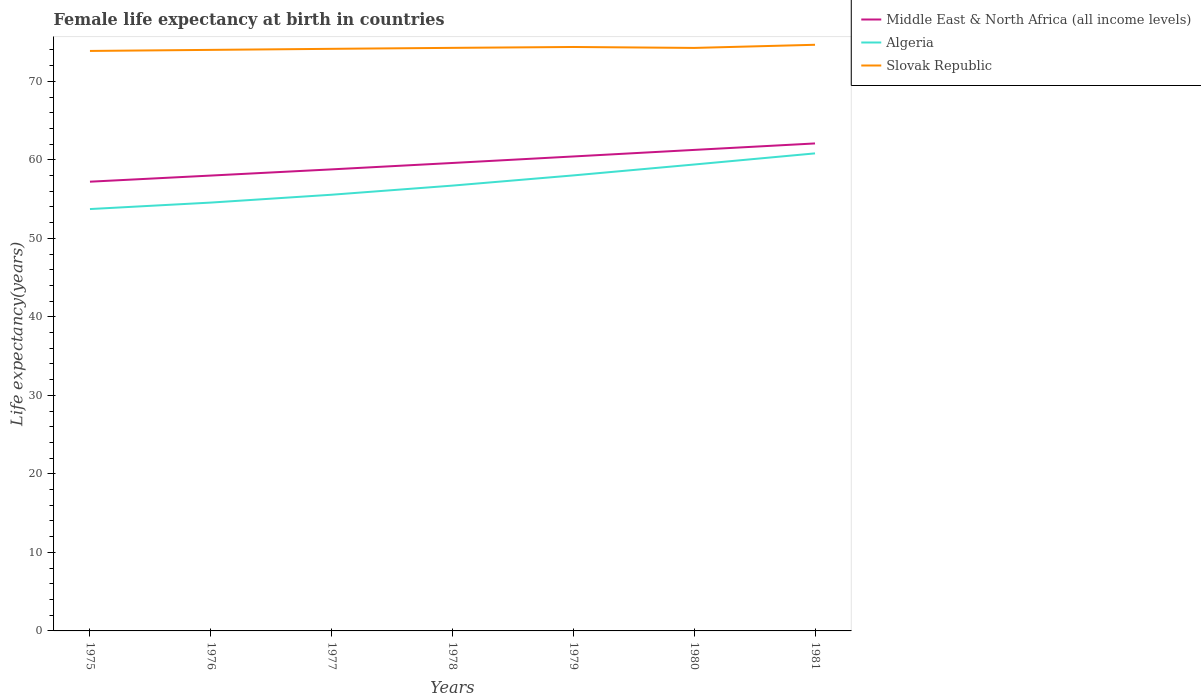Is the number of lines equal to the number of legend labels?
Offer a terse response. Yes. Across all years, what is the maximum female life expectancy at birth in Slovak Republic?
Ensure brevity in your answer.  73.87. In which year was the female life expectancy at birth in Slovak Republic maximum?
Your answer should be compact. 1975. What is the total female life expectancy at birth in Algeria in the graph?
Offer a very short reply. -1.39. What is the difference between the highest and the second highest female life expectancy at birth in Slovak Republic?
Offer a terse response. 0.78. Is the female life expectancy at birth in Slovak Republic strictly greater than the female life expectancy at birth in Middle East & North Africa (all income levels) over the years?
Offer a very short reply. No. What is the difference between two consecutive major ticks on the Y-axis?
Make the answer very short. 10. Are the values on the major ticks of Y-axis written in scientific E-notation?
Give a very brief answer. No. Does the graph contain any zero values?
Offer a very short reply. No. How many legend labels are there?
Make the answer very short. 3. How are the legend labels stacked?
Offer a terse response. Vertical. What is the title of the graph?
Give a very brief answer. Female life expectancy at birth in countries. What is the label or title of the Y-axis?
Offer a very short reply. Life expectancy(years). What is the Life expectancy(years) in Middle East & North Africa (all income levels) in 1975?
Your answer should be very brief. 57.21. What is the Life expectancy(years) in Algeria in 1975?
Offer a terse response. 53.73. What is the Life expectancy(years) in Slovak Republic in 1975?
Your answer should be very brief. 73.87. What is the Life expectancy(years) of Middle East & North Africa (all income levels) in 1976?
Offer a very short reply. 57.99. What is the Life expectancy(years) in Algeria in 1976?
Keep it short and to the point. 54.55. What is the Life expectancy(years) of Slovak Republic in 1976?
Keep it short and to the point. 74. What is the Life expectancy(years) in Middle East & North Africa (all income levels) in 1977?
Keep it short and to the point. 58.78. What is the Life expectancy(years) in Algeria in 1977?
Provide a succinct answer. 55.55. What is the Life expectancy(years) of Slovak Republic in 1977?
Give a very brief answer. 74.14. What is the Life expectancy(years) in Middle East & North Africa (all income levels) in 1978?
Ensure brevity in your answer.  59.6. What is the Life expectancy(years) in Algeria in 1978?
Offer a terse response. 56.72. What is the Life expectancy(years) in Slovak Republic in 1978?
Your answer should be compact. 74.26. What is the Life expectancy(years) of Middle East & North Africa (all income levels) in 1979?
Ensure brevity in your answer.  60.43. What is the Life expectancy(years) in Algeria in 1979?
Offer a terse response. 58.01. What is the Life expectancy(years) of Slovak Republic in 1979?
Ensure brevity in your answer.  74.37. What is the Life expectancy(years) of Middle East & North Africa (all income levels) in 1980?
Keep it short and to the point. 61.26. What is the Life expectancy(years) of Algeria in 1980?
Give a very brief answer. 59.4. What is the Life expectancy(years) in Slovak Republic in 1980?
Your answer should be compact. 74.25. What is the Life expectancy(years) in Middle East & North Africa (all income levels) in 1981?
Make the answer very short. 62.09. What is the Life expectancy(years) of Algeria in 1981?
Your answer should be very brief. 60.82. What is the Life expectancy(years) in Slovak Republic in 1981?
Your answer should be very brief. 74.65. Across all years, what is the maximum Life expectancy(years) in Middle East & North Africa (all income levels)?
Provide a short and direct response. 62.09. Across all years, what is the maximum Life expectancy(years) in Algeria?
Provide a succinct answer. 60.82. Across all years, what is the maximum Life expectancy(years) of Slovak Republic?
Your answer should be very brief. 74.65. Across all years, what is the minimum Life expectancy(years) in Middle East & North Africa (all income levels)?
Make the answer very short. 57.21. Across all years, what is the minimum Life expectancy(years) of Algeria?
Provide a short and direct response. 53.73. Across all years, what is the minimum Life expectancy(years) of Slovak Republic?
Offer a terse response. 73.87. What is the total Life expectancy(years) in Middle East & North Africa (all income levels) in the graph?
Your answer should be very brief. 417.36. What is the total Life expectancy(years) of Algeria in the graph?
Your response must be concise. 398.79. What is the total Life expectancy(years) in Slovak Republic in the graph?
Give a very brief answer. 519.53. What is the difference between the Life expectancy(years) of Middle East & North Africa (all income levels) in 1975 and that in 1976?
Your answer should be very brief. -0.78. What is the difference between the Life expectancy(years) in Algeria in 1975 and that in 1976?
Your answer should be compact. -0.82. What is the difference between the Life expectancy(years) of Slovak Republic in 1975 and that in 1976?
Provide a succinct answer. -0.14. What is the difference between the Life expectancy(years) in Middle East & North Africa (all income levels) in 1975 and that in 1977?
Provide a short and direct response. -1.57. What is the difference between the Life expectancy(years) of Algeria in 1975 and that in 1977?
Give a very brief answer. -1.82. What is the difference between the Life expectancy(years) in Slovak Republic in 1975 and that in 1977?
Give a very brief answer. -0.27. What is the difference between the Life expectancy(years) in Middle East & North Africa (all income levels) in 1975 and that in 1978?
Make the answer very short. -2.38. What is the difference between the Life expectancy(years) in Algeria in 1975 and that in 1978?
Offer a very short reply. -2.99. What is the difference between the Life expectancy(years) in Slovak Republic in 1975 and that in 1978?
Give a very brief answer. -0.39. What is the difference between the Life expectancy(years) in Middle East & North Africa (all income levels) in 1975 and that in 1979?
Provide a short and direct response. -3.21. What is the difference between the Life expectancy(years) of Algeria in 1975 and that in 1979?
Ensure brevity in your answer.  -4.29. What is the difference between the Life expectancy(years) in Slovak Republic in 1975 and that in 1979?
Keep it short and to the point. -0.5. What is the difference between the Life expectancy(years) in Middle East & North Africa (all income levels) in 1975 and that in 1980?
Give a very brief answer. -4.05. What is the difference between the Life expectancy(years) in Algeria in 1975 and that in 1980?
Your answer should be very brief. -5.67. What is the difference between the Life expectancy(years) in Slovak Republic in 1975 and that in 1980?
Provide a short and direct response. -0.38. What is the difference between the Life expectancy(years) of Middle East & North Africa (all income levels) in 1975 and that in 1981?
Offer a very short reply. -4.87. What is the difference between the Life expectancy(years) in Algeria in 1975 and that in 1981?
Ensure brevity in your answer.  -7.09. What is the difference between the Life expectancy(years) of Slovak Republic in 1975 and that in 1981?
Make the answer very short. -0.78. What is the difference between the Life expectancy(years) in Middle East & North Africa (all income levels) in 1976 and that in 1977?
Your answer should be very brief. -0.79. What is the difference between the Life expectancy(years) in Algeria in 1976 and that in 1977?
Keep it short and to the point. -1. What is the difference between the Life expectancy(years) in Slovak Republic in 1976 and that in 1977?
Make the answer very short. -0.13. What is the difference between the Life expectancy(years) of Middle East & North Africa (all income levels) in 1976 and that in 1978?
Ensure brevity in your answer.  -1.6. What is the difference between the Life expectancy(years) of Algeria in 1976 and that in 1978?
Your answer should be compact. -2.16. What is the difference between the Life expectancy(years) in Slovak Republic in 1976 and that in 1978?
Keep it short and to the point. -0.26. What is the difference between the Life expectancy(years) in Middle East & North Africa (all income levels) in 1976 and that in 1979?
Your answer should be compact. -2.43. What is the difference between the Life expectancy(years) of Algeria in 1976 and that in 1979?
Make the answer very short. -3.46. What is the difference between the Life expectancy(years) in Slovak Republic in 1976 and that in 1979?
Offer a very short reply. -0.37. What is the difference between the Life expectancy(years) in Middle East & North Africa (all income levels) in 1976 and that in 1980?
Offer a terse response. -3.27. What is the difference between the Life expectancy(years) in Algeria in 1976 and that in 1980?
Keep it short and to the point. -4.85. What is the difference between the Life expectancy(years) of Slovak Republic in 1976 and that in 1980?
Offer a terse response. -0.25. What is the difference between the Life expectancy(years) of Middle East & North Africa (all income levels) in 1976 and that in 1981?
Offer a very short reply. -4.09. What is the difference between the Life expectancy(years) of Algeria in 1976 and that in 1981?
Your answer should be very brief. -6.27. What is the difference between the Life expectancy(years) of Slovak Republic in 1976 and that in 1981?
Keep it short and to the point. -0.65. What is the difference between the Life expectancy(years) of Middle East & North Africa (all income levels) in 1977 and that in 1978?
Ensure brevity in your answer.  -0.82. What is the difference between the Life expectancy(years) in Algeria in 1977 and that in 1978?
Provide a succinct answer. -1.16. What is the difference between the Life expectancy(years) of Slovak Republic in 1977 and that in 1978?
Provide a succinct answer. -0.12. What is the difference between the Life expectancy(years) in Middle East & North Africa (all income levels) in 1977 and that in 1979?
Offer a terse response. -1.65. What is the difference between the Life expectancy(years) of Algeria in 1977 and that in 1979?
Provide a succinct answer. -2.46. What is the difference between the Life expectancy(years) in Slovak Republic in 1977 and that in 1979?
Give a very brief answer. -0.23. What is the difference between the Life expectancy(years) of Middle East & North Africa (all income levels) in 1977 and that in 1980?
Make the answer very short. -2.48. What is the difference between the Life expectancy(years) of Algeria in 1977 and that in 1980?
Your answer should be compact. -3.85. What is the difference between the Life expectancy(years) in Slovak Republic in 1977 and that in 1980?
Your answer should be very brief. -0.12. What is the difference between the Life expectancy(years) in Middle East & North Africa (all income levels) in 1977 and that in 1981?
Make the answer very short. -3.3. What is the difference between the Life expectancy(years) of Algeria in 1977 and that in 1981?
Ensure brevity in your answer.  -5.27. What is the difference between the Life expectancy(years) of Slovak Republic in 1977 and that in 1981?
Provide a short and direct response. -0.52. What is the difference between the Life expectancy(years) of Middle East & North Africa (all income levels) in 1978 and that in 1979?
Your response must be concise. -0.83. What is the difference between the Life expectancy(years) of Algeria in 1978 and that in 1979?
Provide a succinct answer. -1.3. What is the difference between the Life expectancy(years) of Slovak Republic in 1978 and that in 1979?
Give a very brief answer. -0.11. What is the difference between the Life expectancy(years) in Middle East & North Africa (all income levels) in 1978 and that in 1980?
Your answer should be very brief. -1.66. What is the difference between the Life expectancy(years) of Algeria in 1978 and that in 1980?
Your answer should be compact. -2.69. What is the difference between the Life expectancy(years) in Slovak Republic in 1978 and that in 1980?
Give a very brief answer. 0.01. What is the difference between the Life expectancy(years) in Middle East & North Africa (all income levels) in 1978 and that in 1981?
Ensure brevity in your answer.  -2.49. What is the difference between the Life expectancy(years) of Algeria in 1978 and that in 1981?
Offer a terse response. -4.1. What is the difference between the Life expectancy(years) of Slovak Republic in 1978 and that in 1981?
Provide a short and direct response. -0.39. What is the difference between the Life expectancy(years) of Middle East & North Africa (all income levels) in 1979 and that in 1980?
Your answer should be very brief. -0.83. What is the difference between the Life expectancy(years) in Algeria in 1979 and that in 1980?
Give a very brief answer. -1.39. What is the difference between the Life expectancy(years) of Slovak Republic in 1979 and that in 1980?
Keep it short and to the point. 0.12. What is the difference between the Life expectancy(years) of Middle East & North Africa (all income levels) in 1979 and that in 1981?
Your answer should be compact. -1.66. What is the difference between the Life expectancy(years) of Algeria in 1979 and that in 1981?
Your answer should be compact. -2.81. What is the difference between the Life expectancy(years) of Slovak Republic in 1979 and that in 1981?
Make the answer very short. -0.28. What is the difference between the Life expectancy(years) in Middle East & North Africa (all income levels) in 1980 and that in 1981?
Provide a short and direct response. -0.82. What is the difference between the Life expectancy(years) of Algeria in 1980 and that in 1981?
Make the answer very short. -1.42. What is the difference between the Life expectancy(years) in Slovak Republic in 1980 and that in 1981?
Offer a terse response. -0.4. What is the difference between the Life expectancy(years) of Middle East & North Africa (all income levels) in 1975 and the Life expectancy(years) of Algeria in 1976?
Keep it short and to the point. 2.66. What is the difference between the Life expectancy(years) in Middle East & North Africa (all income levels) in 1975 and the Life expectancy(years) in Slovak Republic in 1976?
Ensure brevity in your answer.  -16.79. What is the difference between the Life expectancy(years) of Algeria in 1975 and the Life expectancy(years) of Slovak Republic in 1976?
Your answer should be very brief. -20.27. What is the difference between the Life expectancy(years) of Middle East & North Africa (all income levels) in 1975 and the Life expectancy(years) of Algeria in 1977?
Ensure brevity in your answer.  1.66. What is the difference between the Life expectancy(years) of Middle East & North Africa (all income levels) in 1975 and the Life expectancy(years) of Slovak Republic in 1977?
Provide a short and direct response. -16.92. What is the difference between the Life expectancy(years) in Algeria in 1975 and the Life expectancy(years) in Slovak Republic in 1977?
Provide a succinct answer. -20.41. What is the difference between the Life expectancy(years) of Middle East & North Africa (all income levels) in 1975 and the Life expectancy(years) of Algeria in 1978?
Make the answer very short. 0.5. What is the difference between the Life expectancy(years) in Middle East & North Africa (all income levels) in 1975 and the Life expectancy(years) in Slovak Republic in 1978?
Offer a very short reply. -17.04. What is the difference between the Life expectancy(years) of Algeria in 1975 and the Life expectancy(years) of Slovak Republic in 1978?
Offer a terse response. -20.53. What is the difference between the Life expectancy(years) of Middle East & North Africa (all income levels) in 1975 and the Life expectancy(years) of Algeria in 1979?
Your answer should be very brief. -0.8. What is the difference between the Life expectancy(years) in Middle East & North Africa (all income levels) in 1975 and the Life expectancy(years) in Slovak Republic in 1979?
Provide a succinct answer. -17.16. What is the difference between the Life expectancy(years) of Algeria in 1975 and the Life expectancy(years) of Slovak Republic in 1979?
Make the answer very short. -20.64. What is the difference between the Life expectancy(years) of Middle East & North Africa (all income levels) in 1975 and the Life expectancy(years) of Algeria in 1980?
Offer a terse response. -2.19. What is the difference between the Life expectancy(years) of Middle East & North Africa (all income levels) in 1975 and the Life expectancy(years) of Slovak Republic in 1980?
Make the answer very short. -17.04. What is the difference between the Life expectancy(years) in Algeria in 1975 and the Life expectancy(years) in Slovak Republic in 1980?
Offer a very short reply. -20.52. What is the difference between the Life expectancy(years) in Middle East & North Africa (all income levels) in 1975 and the Life expectancy(years) in Algeria in 1981?
Offer a terse response. -3.61. What is the difference between the Life expectancy(years) in Middle East & North Africa (all income levels) in 1975 and the Life expectancy(years) in Slovak Republic in 1981?
Offer a very short reply. -17.44. What is the difference between the Life expectancy(years) of Algeria in 1975 and the Life expectancy(years) of Slovak Republic in 1981?
Your answer should be very brief. -20.92. What is the difference between the Life expectancy(years) of Middle East & North Africa (all income levels) in 1976 and the Life expectancy(years) of Algeria in 1977?
Your answer should be very brief. 2.44. What is the difference between the Life expectancy(years) in Middle East & North Africa (all income levels) in 1976 and the Life expectancy(years) in Slovak Republic in 1977?
Give a very brief answer. -16.14. What is the difference between the Life expectancy(years) of Algeria in 1976 and the Life expectancy(years) of Slovak Republic in 1977?
Give a very brief answer. -19.58. What is the difference between the Life expectancy(years) of Middle East & North Africa (all income levels) in 1976 and the Life expectancy(years) of Algeria in 1978?
Offer a very short reply. 1.28. What is the difference between the Life expectancy(years) of Middle East & North Africa (all income levels) in 1976 and the Life expectancy(years) of Slovak Republic in 1978?
Your response must be concise. -16.27. What is the difference between the Life expectancy(years) of Algeria in 1976 and the Life expectancy(years) of Slovak Republic in 1978?
Offer a very short reply. -19.7. What is the difference between the Life expectancy(years) in Middle East & North Africa (all income levels) in 1976 and the Life expectancy(years) in Algeria in 1979?
Provide a short and direct response. -0.02. What is the difference between the Life expectancy(years) in Middle East & North Africa (all income levels) in 1976 and the Life expectancy(years) in Slovak Republic in 1979?
Make the answer very short. -16.38. What is the difference between the Life expectancy(years) in Algeria in 1976 and the Life expectancy(years) in Slovak Republic in 1979?
Give a very brief answer. -19.82. What is the difference between the Life expectancy(years) in Middle East & North Africa (all income levels) in 1976 and the Life expectancy(years) in Algeria in 1980?
Offer a terse response. -1.41. What is the difference between the Life expectancy(years) in Middle East & North Africa (all income levels) in 1976 and the Life expectancy(years) in Slovak Republic in 1980?
Offer a very short reply. -16.26. What is the difference between the Life expectancy(years) of Algeria in 1976 and the Life expectancy(years) of Slovak Republic in 1980?
Provide a short and direct response. -19.7. What is the difference between the Life expectancy(years) in Middle East & North Africa (all income levels) in 1976 and the Life expectancy(years) in Algeria in 1981?
Provide a short and direct response. -2.83. What is the difference between the Life expectancy(years) of Middle East & North Africa (all income levels) in 1976 and the Life expectancy(years) of Slovak Republic in 1981?
Provide a short and direct response. -16.66. What is the difference between the Life expectancy(years) of Algeria in 1976 and the Life expectancy(years) of Slovak Republic in 1981?
Provide a short and direct response. -20.1. What is the difference between the Life expectancy(years) of Middle East & North Africa (all income levels) in 1977 and the Life expectancy(years) of Algeria in 1978?
Offer a terse response. 2.07. What is the difference between the Life expectancy(years) of Middle East & North Africa (all income levels) in 1977 and the Life expectancy(years) of Slovak Republic in 1978?
Your answer should be compact. -15.48. What is the difference between the Life expectancy(years) of Algeria in 1977 and the Life expectancy(years) of Slovak Republic in 1978?
Offer a terse response. -18.7. What is the difference between the Life expectancy(years) of Middle East & North Africa (all income levels) in 1977 and the Life expectancy(years) of Algeria in 1979?
Give a very brief answer. 0.77. What is the difference between the Life expectancy(years) in Middle East & North Africa (all income levels) in 1977 and the Life expectancy(years) in Slovak Republic in 1979?
Provide a short and direct response. -15.59. What is the difference between the Life expectancy(years) of Algeria in 1977 and the Life expectancy(years) of Slovak Republic in 1979?
Your answer should be compact. -18.82. What is the difference between the Life expectancy(years) in Middle East & North Africa (all income levels) in 1977 and the Life expectancy(years) in Algeria in 1980?
Give a very brief answer. -0.62. What is the difference between the Life expectancy(years) in Middle East & North Africa (all income levels) in 1977 and the Life expectancy(years) in Slovak Republic in 1980?
Your response must be concise. -15.47. What is the difference between the Life expectancy(years) in Algeria in 1977 and the Life expectancy(years) in Slovak Republic in 1980?
Provide a short and direct response. -18.7. What is the difference between the Life expectancy(years) of Middle East & North Africa (all income levels) in 1977 and the Life expectancy(years) of Algeria in 1981?
Provide a short and direct response. -2.04. What is the difference between the Life expectancy(years) of Middle East & North Africa (all income levels) in 1977 and the Life expectancy(years) of Slovak Republic in 1981?
Your response must be concise. -15.87. What is the difference between the Life expectancy(years) of Algeria in 1977 and the Life expectancy(years) of Slovak Republic in 1981?
Offer a very short reply. -19.1. What is the difference between the Life expectancy(years) in Middle East & North Africa (all income levels) in 1978 and the Life expectancy(years) in Algeria in 1979?
Keep it short and to the point. 1.58. What is the difference between the Life expectancy(years) in Middle East & North Africa (all income levels) in 1978 and the Life expectancy(years) in Slovak Republic in 1979?
Keep it short and to the point. -14.77. What is the difference between the Life expectancy(years) of Algeria in 1978 and the Life expectancy(years) of Slovak Republic in 1979?
Offer a terse response. -17.65. What is the difference between the Life expectancy(years) of Middle East & North Africa (all income levels) in 1978 and the Life expectancy(years) of Algeria in 1980?
Your answer should be very brief. 0.2. What is the difference between the Life expectancy(years) of Middle East & North Africa (all income levels) in 1978 and the Life expectancy(years) of Slovak Republic in 1980?
Provide a succinct answer. -14.65. What is the difference between the Life expectancy(years) of Algeria in 1978 and the Life expectancy(years) of Slovak Republic in 1980?
Provide a short and direct response. -17.53. What is the difference between the Life expectancy(years) in Middle East & North Africa (all income levels) in 1978 and the Life expectancy(years) in Algeria in 1981?
Offer a terse response. -1.22. What is the difference between the Life expectancy(years) in Middle East & North Africa (all income levels) in 1978 and the Life expectancy(years) in Slovak Republic in 1981?
Give a very brief answer. -15.05. What is the difference between the Life expectancy(years) of Algeria in 1978 and the Life expectancy(years) of Slovak Republic in 1981?
Ensure brevity in your answer.  -17.93. What is the difference between the Life expectancy(years) in Middle East & North Africa (all income levels) in 1979 and the Life expectancy(years) in Algeria in 1980?
Your answer should be very brief. 1.03. What is the difference between the Life expectancy(years) of Middle East & North Africa (all income levels) in 1979 and the Life expectancy(years) of Slovak Republic in 1980?
Your response must be concise. -13.82. What is the difference between the Life expectancy(years) in Algeria in 1979 and the Life expectancy(years) in Slovak Republic in 1980?
Keep it short and to the point. -16.24. What is the difference between the Life expectancy(years) of Middle East & North Africa (all income levels) in 1979 and the Life expectancy(years) of Algeria in 1981?
Provide a short and direct response. -0.39. What is the difference between the Life expectancy(years) of Middle East & North Africa (all income levels) in 1979 and the Life expectancy(years) of Slovak Republic in 1981?
Your answer should be compact. -14.22. What is the difference between the Life expectancy(years) in Algeria in 1979 and the Life expectancy(years) in Slovak Republic in 1981?
Keep it short and to the point. -16.64. What is the difference between the Life expectancy(years) of Middle East & North Africa (all income levels) in 1980 and the Life expectancy(years) of Algeria in 1981?
Ensure brevity in your answer.  0.44. What is the difference between the Life expectancy(years) of Middle East & North Africa (all income levels) in 1980 and the Life expectancy(years) of Slovak Republic in 1981?
Provide a short and direct response. -13.39. What is the difference between the Life expectancy(years) of Algeria in 1980 and the Life expectancy(years) of Slovak Republic in 1981?
Your answer should be compact. -15.25. What is the average Life expectancy(years) of Middle East & North Africa (all income levels) per year?
Your answer should be compact. 59.62. What is the average Life expectancy(years) in Algeria per year?
Provide a succinct answer. 56.97. What is the average Life expectancy(years) of Slovak Republic per year?
Give a very brief answer. 74.22. In the year 1975, what is the difference between the Life expectancy(years) in Middle East & North Africa (all income levels) and Life expectancy(years) in Algeria?
Your answer should be compact. 3.49. In the year 1975, what is the difference between the Life expectancy(years) of Middle East & North Africa (all income levels) and Life expectancy(years) of Slovak Republic?
Give a very brief answer. -16.65. In the year 1975, what is the difference between the Life expectancy(years) of Algeria and Life expectancy(years) of Slovak Republic?
Ensure brevity in your answer.  -20.14. In the year 1976, what is the difference between the Life expectancy(years) of Middle East & North Africa (all income levels) and Life expectancy(years) of Algeria?
Provide a short and direct response. 3.44. In the year 1976, what is the difference between the Life expectancy(years) of Middle East & North Africa (all income levels) and Life expectancy(years) of Slovak Republic?
Make the answer very short. -16.01. In the year 1976, what is the difference between the Life expectancy(years) in Algeria and Life expectancy(years) in Slovak Republic?
Your answer should be compact. -19.45. In the year 1977, what is the difference between the Life expectancy(years) in Middle East & North Africa (all income levels) and Life expectancy(years) in Algeria?
Keep it short and to the point. 3.23. In the year 1977, what is the difference between the Life expectancy(years) in Middle East & North Africa (all income levels) and Life expectancy(years) in Slovak Republic?
Your answer should be compact. -15.35. In the year 1977, what is the difference between the Life expectancy(years) in Algeria and Life expectancy(years) in Slovak Republic?
Your answer should be very brief. -18.58. In the year 1978, what is the difference between the Life expectancy(years) of Middle East & North Africa (all income levels) and Life expectancy(years) of Algeria?
Make the answer very short. 2.88. In the year 1978, what is the difference between the Life expectancy(years) in Middle East & North Africa (all income levels) and Life expectancy(years) in Slovak Republic?
Provide a short and direct response. -14.66. In the year 1978, what is the difference between the Life expectancy(years) of Algeria and Life expectancy(years) of Slovak Republic?
Make the answer very short. -17.54. In the year 1979, what is the difference between the Life expectancy(years) of Middle East & North Africa (all income levels) and Life expectancy(years) of Algeria?
Your answer should be compact. 2.41. In the year 1979, what is the difference between the Life expectancy(years) in Middle East & North Africa (all income levels) and Life expectancy(years) in Slovak Republic?
Offer a very short reply. -13.94. In the year 1979, what is the difference between the Life expectancy(years) in Algeria and Life expectancy(years) in Slovak Republic?
Keep it short and to the point. -16.36. In the year 1980, what is the difference between the Life expectancy(years) of Middle East & North Africa (all income levels) and Life expectancy(years) of Algeria?
Offer a very short reply. 1.86. In the year 1980, what is the difference between the Life expectancy(years) in Middle East & North Africa (all income levels) and Life expectancy(years) in Slovak Republic?
Provide a short and direct response. -12.99. In the year 1980, what is the difference between the Life expectancy(years) in Algeria and Life expectancy(years) in Slovak Republic?
Keep it short and to the point. -14.85. In the year 1981, what is the difference between the Life expectancy(years) in Middle East & North Africa (all income levels) and Life expectancy(years) in Algeria?
Give a very brief answer. 1.27. In the year 1981, what is the difference between the Life expectancy(years) in Middle East & North Africa (all income levels) and Life expectancy(years) in Slovak Republic?
Give a very brief answer. -12.56. In the year 1981, what is the difference between the Life expectancy(years) in Algeria and Life expectancy(years) in Slovak Republic?
Provide a succinct answer. -13.83. What is the ratio of the Life expectancy(years) in Middle East & North Africa (all income levels) in 1975 to that in 1976?
Make the answer very short. 0.99. What is the ratio of the Life expectancy(years) of Algeria in 1975 to that in 1976?
Provide a short and direct response. 0.98. What is the ratio of the Life expectancy(years) in Middle East & North Africa (all income levels) in 1975 to that in 1977?
Provide a succinct answer. 0.97. What is the ratio of the Life expectancy(years) in Algeria in 1975 to that in 1977?
Make the answer very short. 0.97. What is the ratio of the Life expectancy(years) in Slovak Republic in 1975 to that in 1977?
Provide a short and direct response. 1. What is the ratio of the Life expectancy(years) in Algeria in 1975 to that in 1978?
Keep it short and to the point. 0.95. What is the ratio of the Life expectancy(years) of Slovak Republic in 1975 to that in 1978?
Give a very brief answer. 0.99. What is the ratio of the Life expectancy(years) in Middle East & North Africa (all income levels) in 1975 to that in 1979?
Ensure brevity in your answer.  0.95. What is the ratio of the Life expectancy(years) in Algeria in 1975 to that in 1979?
Offer a very short reply. 0.93. What is the ratio of the Life expectancy(years) in Slovak Republic in 1975 to that in 1979?
Keep it short and to the point. 0.99. What is the ratio of the Life expectancy(years) of Middle East & North Africa (all income levels) in 1975 to that in 1980?
Your answer should be very brief. 0.93. What is the ratio of the Life expectancy(years) in Algeria in 1975 to that in 1980?
Give a very brief answer. 0.9. What is the ratio of the Life expectancy(years) in Middle East & North Africa (all income levels) in 1975 to that in 1981?
Your answer should be very brief. 0.92. What is the ratio of the Life expectancy(years) of Algeria in 1975 to that in 1981?
Your answer should be compact. 0.88. What is the ratio of the Life expectancy(years) in Middle East & North Africa (all income levels) in 1976 to that in 1977?
Your response must be concise. 0.99. What is the ratio of the Life expectancy(years) of Middle East & North Africa (all income levels) in 1976 to that in 1978?
Give a very brief answer. 0.97. What is the ratio of the Life expectancy(years) of Algeria in 1976 to that in 1978?
Offer a very short reply. 0.96. What is the ratio of the Life expectancy(years) of Middle East & North Africa (all income levels) in 1976 to that in 1979?
Offer a terse response. 0.96. What is the ratio of the Life expectancy(years) of Algeria in 1976 to that in 1979?
Offer a terse response. 0.94. What is the ratio of the Life expectancy(years) in Middle East & North Africa (all income levels) in 1976 to that in 1980?
Your response must be concise. 0.95. What is the ratio of the Life expectancy(years) in Algeria in 1976 to that in 1980?
Ensure brevity in your answer.  0.92. What is the ratio of the Life expectancy(years) in Middle East & North Africa (all income levels) in 1976 to that in 1981?
Keep it short and to the point. 0.93. What is the ratio of the Life expectancy(years) in Algeria in 1976 to that in 1981?
Make the answer very short. 0.9. What is the ratio of the Life expectancy(years) of Slovak Republic in 1976 to that in 1981?
Your response must be concise. 0.99. What is the ratio of the Life expectancy(years) of Middle East & North Africa (all income levels) in 1977 to that in 1978?
Keep it short and to the point. 0.99. What is the ratio of the Life expectancy(years) of Algeria in 1977 to that in 1978?
Your answer should be compact. 0.98. What is the ratio of the Life expectancy(years) of Slovak Republic in 1977 to that in 1978?
Ensure brevity in your answer.  1. What is the ratio of the Life expectancy(years) in Middle East & North Africa (all income levels) in 1977 to that in 1979?
Offer a terse response. 0.97. What is the ratio of the Life expectancy(years) of Algeria in 1977 to that in 1979?
Provide a short and direct response. 0.96. What is the ratio of the Life expectancy(years) of Slovak Republic in 1977 to that in 1979?
Your answer should be very brief. 1. What is the ratio of the Life expectancy(years) in Middle East & North Africa (all income levels) in 1977 to that in 1980?
Make the answer very short. 0.96. What is the ratio of the Life expectancy(years) in Algeria in 1977 to that in 1980?
Give a very brief answer. 0.94. What is the ratio of the Life expectancy(years) of Slovak Republic in 1977 to that in 1980?
Provide a succinct answer. 1. What is the ratio of the Life expectancy(years) of Middle East & North Africa (all income levels) in 1977 to that in 1981?
Ensure brevity in your answer.  0.95. What is the ratio of the Life expectancy(years) in Algeria in 1977 to that in 1981?
Offer a very short reply. 0.91. What is the ratio of the Life expectancy(years) of Middle East & North Africa (all income levels) in 1978 to that in 1979?
Ensure brevity in your answer.  0.99. What is the ratio of the Life expectancy(years) of Algeria in 1978 to that in 1979?
Your answer should be compact. 0.98. What is the ratio of the Life expectancy(years) of Middle East & North Africa (all income levels) in 1978 to that in 1980?
Offer a very short reply. 0.97. What is the ratio of the Life expectancy(years) of Algeria in 1978 to that in 1980?
Your response must be concise. 0.95. What is the ratio of the Life expectancy(years) of Slovak Republic in 1978 to that in 1980?
Provide a short and direct response. 1. What is the ratio of the Life expectancy(years) of Middle East & North Africa (all income levels) in 1978 to that in 1981?
Offer a terse response. 0.96. What is the ratio of the Life expectancy(years) of Algeria in 1978 to that in 1981?
Offer a terse response. 0.93. What is the ratio of the Life expectancy(years) of Middle East & North Africa (all income levels) in 1979 to that in 1980?
Make the answer very short. 0.99. What is the ratio of the Life expectancy(years) in Algeria in 1979 to that in 1980?
Your answer should be compact. 0.98. What is the ratio of the Life expectancy(years) of Slovak Republic in 1979 to that in 1980?
Give a very brief answer. 1. What is the ratio of the Life expectancy(years) in Middle East & North Africa (all income levels) in 1979 to that in 1981?
Ensure brevity in your answer.  0.97. What is the ratio of the Life expectancy(years) in Algeria in 1979 to that in 1981?
Offer a very short reply. 0.95. What is the ratio of the Life expectancy(years) in Middle East & North Africa (all income levels) in 1980 to that in 1981?
Offer a very short reply. 0.99. What is the ratio of the Life expectancy(years) of Algeria in 1980 to that in 1981?
Your answer should be compact. 0.98. What is the difference between the highest and the second highest Life expectancy(years) of Middle East & North Africa (all income levels)?
Your response must be concise. 0.82. What is the difference between the highest and the second highest Life expectancy(years) of Algeria?
Provide a succinct answer. 1.42. What is the difference between the highest and the second highest Life expectancy(years) of Slovak Republic?
Provide a short and direct response. 0.28. What is the difference between the highest and the lowest Life expectancy(years) in Middle East & North Africa (all income levels)?
Make the answer very short. 4.87. What is the difference between the highest and the lowest Life expectancy(years) of Algeria?
Your response must be concise. 7.09. What is the difference between the highest and the lowest Life expectancy(years) in Slovak Republic?
Ensure brevity in your answer.  0.78. 